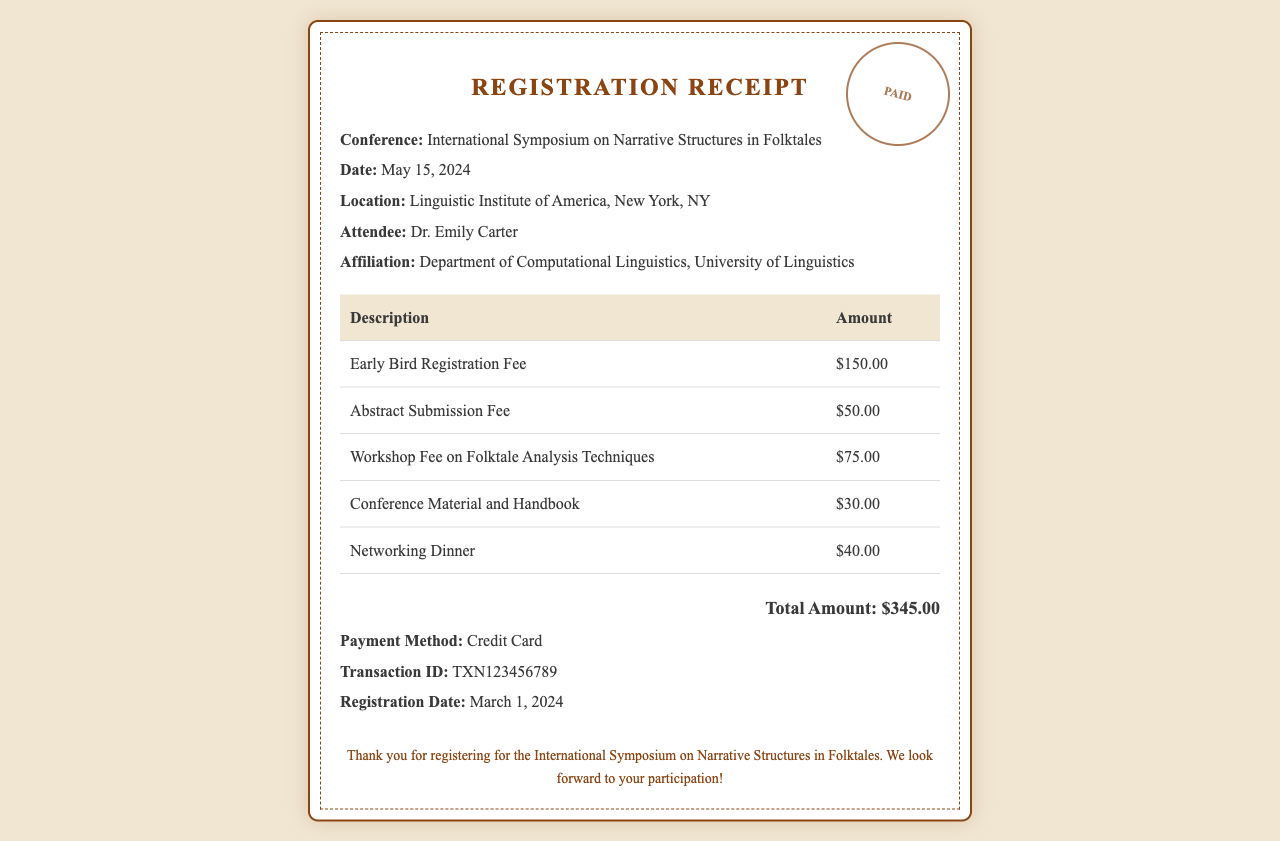What is the name of the conference? The name of the conference is stated in the document as "International Symposium on Narrative Structures in Folktales."
Answer: International Symposium on Narrative Structures in Folktales What is the total amount paid for registration? The total amount is summarized at the bottom of the receipt, which is $345.00.
Answer: $345.00 Who is the attendee? The name of the attendee is provided as "Dr. Emily Carter."
Answer: Dr. Emily Carter What is the registration date? The document mentions that the registration date is March 1, 2024.
Answer: March 1, 2024 How much is the workshop fee? The receipt explicitly states the workshop fee is $75.00.
Answer: $75.00 Where is the conference located? The location of the conference is provided in the document as "Linguistic Institute of America, New York, NY."
Answer: Linguistic Institute of America, New York, NY What payment method was used? The payment method is specified as "Credit Card" in the receipt.
Answer: Credit Card What date is the conference scheduled for? The document indicates that the conference is scheduled for May 15, 2024.
Answer: May 15, 2024 What is the transaction ID? The receipt includes the transaction ID, which is "TXN123456789."
Answer: TXN123456789 